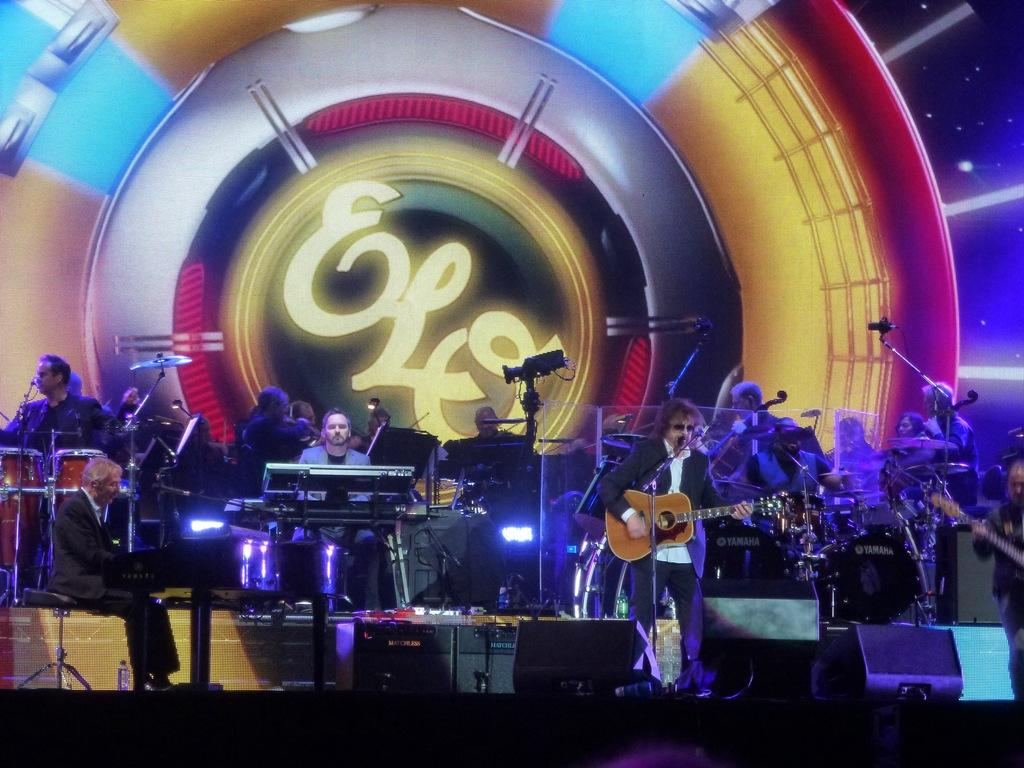What is happening in the image? There is a group of people in the image, and they are playing musical instruments. What are the people doing in the image? The people are playing musical instruments. What type of building can be seen in the background of the image? There is no building visible in the image; it only shows a group of people playing musical instruments. 